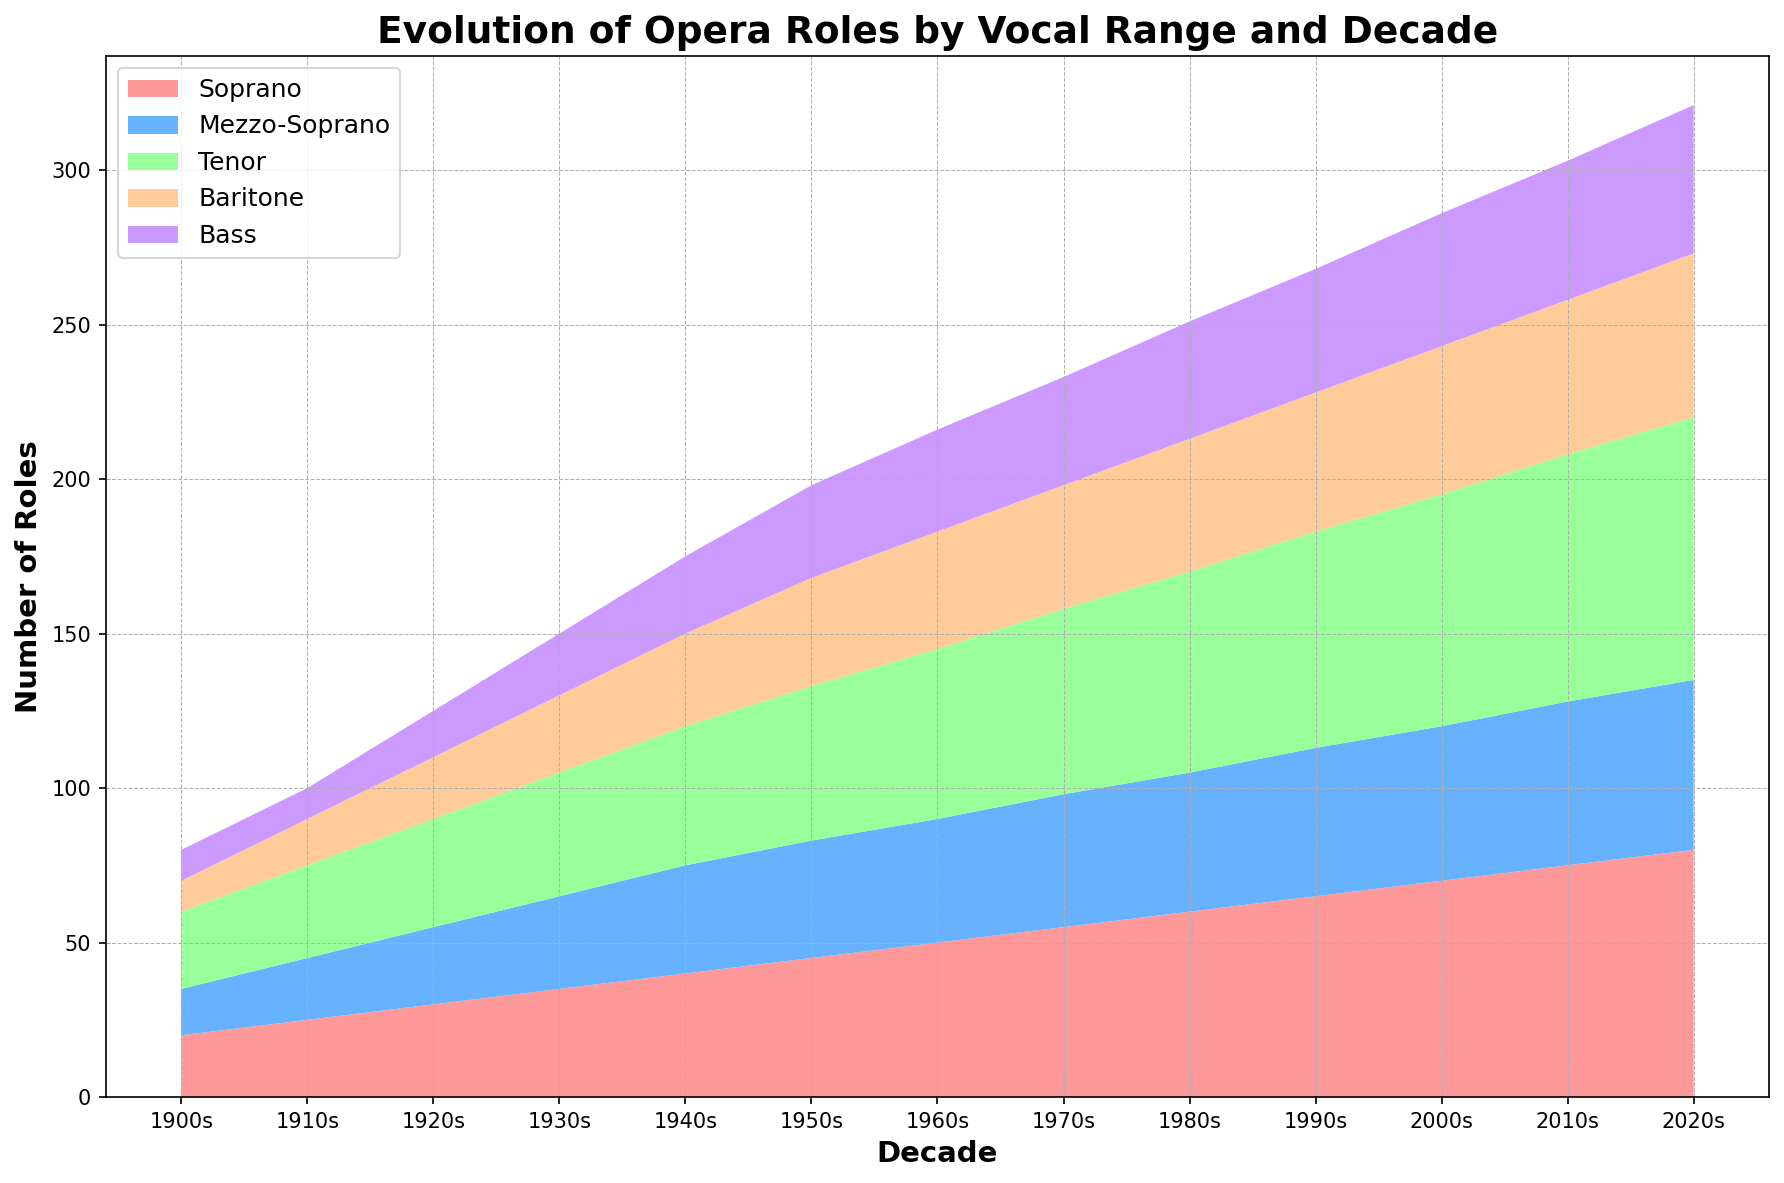What vocal range had the most significant increase in roles from 1900s to 2020s? To find the vocal range with the most significant increase, we look at the change in the number of roles from 1900s to 2020s for each range. Soprano increased from 20 to 80, Mezzo-Soprano from 15 to 55, Tenor from 25 to 85, Baritone from 10 to 53, and Bass from 10 to 48. The Tenor had the most significant increase (85 - 25 = 60).
Answer: Tenor Between which decades did the Soprano roles experience the largest single-decade increase? We need to check the difference in Soprano roles between each consecutive decade. The differences are: 1900s to 1910s: +5, 1910s to 1920s: +5, 1920s to 1930s: +5, 1930s to 1940s: +5, 1940s to 1950s: +5, 1950s to 1960s: +5, 1960s to 1970s: +5, 1970s to 1980s: +5, 1980s to 1990s: +5, 1990s to 2000s: +5, 2000s to 2010s: +5, 2010s to 2020s: +5. All increases are the same.
Answer: 1900s to 1910s (and all subsequent) In the 1990s, what is the total number of opera roles across all vocal ranges? To get the total number of opera roles in the 1990s, sum the values of all vocal ranges for that decade: 65 (Soprano) + 48 (Mezzo-Soprano) + 70 (Tenor) + 45 (Baritone) + 40 (Bass) = 268.
Answer: 268 Which decade saw the first appearance of a noticeable trend in the number of Mezzo-Soprano roles outpacing the number of Bass roles? To determine this, we compare Mezzo-Soprano and Bass roles by decade and look for when Mezzo-Soprano consistently exceeds Bass. From the data: 1900s: 15 vs 10, 1910s: 20 vs 10, 1920s: 25 vs 15, 1930s: 30 vs 20, 1940s: 35 vs 25, 1950s: 38 vs 30, 1960s: 40 vs 33, 1970s: 43 vs 35, 1980s: 45 vs 38, 1990s: 48 vs 40, 2000s: 50 vs 43, 2010s: 53 vs 45, 2020s: 55 vs 48. A consistent trend where Mezzo-Soprano outpaces Bass is noticeable from the 1900s onwards.
Answer: 1900s How many total roles are accounted for in the 2000s and what percentage does the Tenor represent? First, sum the total number of roles across all vocal ranges in the 2000s: 70 (Soprano) + 50 (Mezzo-Soprano) + 75 (Tenor) + 48 (Baritone) + 43 (Bass) = 286. Tenor roles in the 2000s are 75. The percentage of Tenor roles is \( \frac{75}{286} \approx 26.2\% \).
Answer: 26.2% What visual attribute indicates the most common vocal range in the 2020s? The height of the areas in an area chart represents the number of roles. In the 2020s, the largest area is for the Tenor, indicating it is the most common vocal range.
Answer: Height of Tenor area Which vocal range had the least number of roles in the 1900s and how did it change by the 2020s? In the 1900s, both Baritone and Bass had the least number of roles (each with 10). By the 2020s, Baritone roles increased to 53, and Bass roles increased to 48.
Answer: Baritone and Bass; increased to 53 and 48 respectively From the 1980s to the 2000s, which vocal range experienced the smallest increase in roles? We need to compare the increase for each vocal range over these two decades. Soprano: 70 - 60 = 10; Mezzo-Soprano: 50 - 45 = 5; Tenor: 75 - 65 = 10; Baritone: 48 - 43 = 5; Bass: 43 - 38 = 5. Mezzo-Soprano, Baritone, and Bass each had the smallest increase with 5 roles.
Answer: Mezzo-Soprano, Baritone, and Bass Comparing Soprano and Baritone roles, in which decade does the difference between their roles first exceed 30? We calculate the differences between Soprano and Baritone for each decade until we find a difference greater than 30. 1900s: 20 - 10 = 10; 1910s: 25 - 15 = 10; 1920s: 30 - 20 = 10; 1930s: 35 - 25 = 10; 1940s: 40 - 30 = 10; 1950s: 45 - 35 = 10; 1960s: 50 - 38 = 12; 1970s: 55 - 40 = 15; 1980s: 60 - 43 = 17; 1990s: 65 - 45 = 20; 2000s: 70 - 48 = 22; 2010s: 75 - 50 = 25; 2020s: 80 - 53 = 27. The difference never exceeds 30 in any decade.
Answer: Never What trend can be observed in the total number of roles across all vocal ranges over the decades? By summing the total roles per decade, we can observe a trend. The totals are increasing in each decade, indicating a growth in the number of opera roles across all vocal ranges over time. This reflects a trend of overall expansion in the genre.
Answer: Increasing trend 